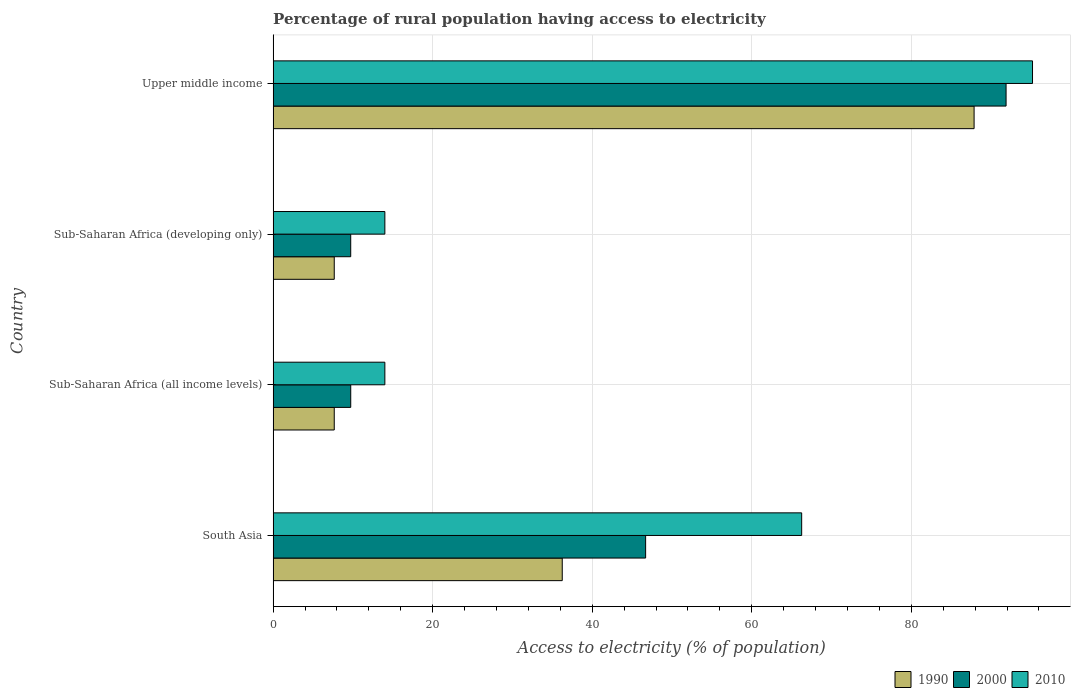How many different coloured bars are there?
Ensure brevity in your answer.  3. How many groups of bars are there?
Provide a succinct answer. 4. Are the number of bars on each tick of the Y-axis equal?
Offer a terse response. Yes. How many bars are there on the 2nd tick from the top?
Your answer should be very brief. 3. How many bars are there on the 1st tick from the bottom?
Provide a short and direct response. 3. What is the label of the 1st group of bars from the top?
Provide a succinct answer. Upper middle income. In how many cases, is the number of bars for a given country not equal to the number of legend labels?
Your answer should be very brief. 0. What is the percentage of rural population having access to electricity in 1990 in South Asia?
Offer a terse response. 36.24. Across all countries, what is the maximum percentage of rural population having access to electricity in 2010?
Offer a very short reply. 95.19. Across all countries, what is the minimum percentage of rural population having access to electricity in 1990?
Make the answer very short. 7.66. In which country was the percentage of rural population having access to electricity in 2000 maximum?
Offer a very short reply. Upper middle income. In which country was the percentage of rural population having access to electricity in 1990 minimum?
Offer a terse response. Sub-Saharan Africa (all income levels). What is the total percentage of rural population having access to electricity in 2000 in the graph?
Offer a terse response. 158.02. What is the difference between the percentage of rural population having access to electricity in 2000 in Sub-Saharan Africa (all income levels) and that in Sub-Saharan Africa (developing only)?
Provide a short and direct response. 0. What is the difference between the percentage of rural population having access to electricity in 2010 in Upper middle income and the percentage of rural population having access to electricity in 2000 in Sub-Saharan Africa (developing only)?
Offer a very short reply. 85.46. What is the average percentage of rural population having access to electricity in 1990 per country?
Offer a terse response. 34.86. What is the difference between the percentage of rural population having access to electricity in 2010 and percentage of rural population having access to electricity in 2000 in Upper middle income?
Offer a very short reply. 3.32. What is the ratio of the percentage of rural population having access to electricity in 2000 in Sub-Saharan Africa (all income levels) to that in Upper middle income?
Offer a terse response. 0.11. Is the difference between the percentage of rural population having access to electricity in 2010 in Sub-Saharan Africa (developing only) and Upper middle income greater than the difference between the percentage of rural population having access to electricity in 2000 in Sub-Saharan Africa (developing only) and Upper middle income?
Provide a short and direct response. Yes. What is the difference between the highest and the second highest percentage of rural population having access to electricity in 1990?
Make the answer very short. 51.63. What is the difference between the highest and the lowest percentage of rural population having access to electricity in 2000?
Offer a terse response. 82.15. In how many countries, is the percentage of rural population having access to electricity in 1990 greater than the average percentage of rural population having access to electricity in 1990 taken over all countries?
Provide a succinct answer. 2. What does the 2nd bar from the bottom in Sub-Saharan Africa (all income levels) represents?
Keep it short and to the point. 2000. Is it the case that in every country, the sum of the percentage of rural population having access to electricity in 1990 and percentage of rural population having access to electricity in 2010 is greater than the percentage of rural population having access to electricity in 2000?
Offer a very short reply. Yes. Does the graph contain grids?
Your answer should be compact. Yes. How many legend labels are there?
Your answer should be very brief. 3. What is the title of the graph?
Keep it short and to the point. Percentage of rural population having access to electricity. Does "2014" appear as one of the legend labels in the graph?
Offer a terse response. No. What is the label or title of the X-axis?
Provide a succinct answer. Access to electricity (% of population). What is the Access to electricity (% of population) in 1990 in South Asia?
Your response must be concise. 36.24. What is the Access to electricity (% of population) of 2000 in South Asia?
Provide a short and direct response. 46.69. What is the Access to electricity (% of population) in 2010 in South Asia?
Your answer should be compact. 66.25. What is the Access to electricity (% of population) of 1990 in Sub-Saharan Africa (all income levels)?
Keep it short and to the point. 7.66. What is the Access to electricity (% of population) in 2000 in Sub-Saharan Africa (all income levels)?
Make the answer very short. 9.73. What is the Access to electricity (% of population) of 2010 in Sub-Saharan Africa (all income levels)?
Make the answer very short. 14.01. What is the Access to electricity (% of population) in 1990 in Sub-Saharan Africa (developing only)?
Provide a succinct answer. 7.66. What is the Access to electricity (% of population) in 2000 in Sub-Saharan Africa (developing only)?
Provide a short and direct response. 9.73. What is the Access to electricity (% of population) of 2010 in Sub-Saharan Africa (developing only)?
Give a very brief answer. 14.01. What is the Access to electricity (% of population) of 1990 in Upper middle income?
Ensure brevity in your answer.  87.87. What is the Access to electricity (% of population) in 2000 in Upper middle income?
Ensure brevity in your answer.  91.87. What is the Access to electricity (% of population) in 2010 in Upper middle income?
Offer a very short reply. 95.19. Across all countries, what is the maximum Access to electricity (% of population) of 1990?
Your response must be concise. 87.87. Across all countries, what is the maximum Access to electricity (% of population) in 2000?
Provide a succinct answer. 91.87. Across all countries, what is the maximum Access to electricity (% of population) of 2010?
Give a very brief answer. 95.19. Across all countries, what is the minimum Access to electricity (% of population) of 1990?
Give a very brief answer. 7.66. Across all countries, what is the minimum Access to electricity (% of population) of 2000?
Offer a terse response. 9.73. Across all countries, what is the minimum Access to electricity (% of population) in 2010?
Your answer should be very brief. 14.01. What is the total Access to electricity (% of population) of 1990 in the graph?
Ensure brevity in your answer.  139.43. What is the total Access to electricity (% of population) in 2000 in the graph?
Your response must be concise. 158.02. What is the total Access to electricity (% of population) of 2010 in the graph?
Ensure brevity in your answer.  189.46. What is the difference between the Access to electricity (% of population) in 1990 in South Asia and that in Sub-Saharan Africa (all income levels)?
Your answer should be very brief. 28.58. What is the difference between the Access to electricity (% of population) in 2000 in South Asia and that in Sub-Saharan Africa (all income levels)?
Offer a very short reply. 36.96. What is the difference between the Access to electricity (% of population) in 2010 in South Asia and that in Sub-Saharan Africa (all income levels)?
Your response must be concise. 52.25. What is the difference between the Access to electricity (% of population) in 1990 in South Asia and that in Sub-Saharan Africa (developing only)?
Provide a succinct answer. 28.58. What is the difference between the Access to electricity (% of population) of 2000 in South Asia and that in Sub-Saharan Africa (developing only)?
Make the answer very short. 36.97. What is the difference between the Access to electricity (% of population) of 2010 in South Asia and that in Sub-Saharan Africa (developing only)?
Offer a terse response. 52.25. What is the difference between the Access to electricity (% of population) of 1990 in South Asia and that in Upper middle income?
Give a very brief answer. -51.62. What is the difference between the Access to electricity (% of population) of 2000 in South Asia and that in Upper middle income?
Ensure brevity in your answer.  -45.18. What is the difference between the Access to electricity (% of population) of 2010 in South Asia and that in Upper middle income?
Your answer should be compact. -28.94. What is the difference between the Access to electricity (% of population) of 1990 in Sub-Saharan Africa (all income levels) and that in Sub-Saharan Africa (developing only)?
Provide a succinct answer. -0. What is the difference between the Access to electricity (% of population) in 2000 in Sub-Saharan Africa (all income levels) and that in Sub-Saharan Africa (developing only)?
Make the answer very short. 0. What is the difference between the Access to electricity (% of population) of 1990 in Sub-Saharan Africa (all income levels) and that in Upper middle income?
Offer a very short reply. -80.2. What is the difference between the Access to electricity (% of population) of 2000 in Sub-Saharan Africa (all income levels) and that in Upper middle income?
Ensure brevity in your answer.  -82.15. What is the difference between the Access to electricity (% of population) in 2010 in Sub-Saharan Africa (all income levels) and that in Upper middle income?
Provide a succinct answer. -81.18. What is the difference between the Access to electricity (% of population) of 1990 in Sub-Saharan Africa (developing only) and that in Upper middle income?
Provide a short and direct response. -80.2. What is the difference between the Access to electricity (% of population) of 2000 in Sub-Saharan Africa (developing only) and that in Upper middle income?
Offer a terse response. -82.15. What is the difference between the Access to electricity (% of population) of 2010 in Sub-Saharan Africa (developing only) and that in Upper middle income?
Offer a terse response. -81.18. What is the difference between the Access to electricity (% of population) of 1990 in South Asia and the Access to electricity (% of population) of 2000 in Sub-Saharan Africa (all income levels)?
Offer a very short reply. 26.51. What is the difference between the Access to electricity (% of population) of 1990 in South Asia and the Access to electricity (% of population) of 2010 in Sub-Saharan Africa (all income levels)?
Give a very brief answer. 22.23. What is the difference between the Access to electricity (% of population) of 2000 in South Asia and the Access to electricity (% of population) of 2010 in Sub-Saharan Africa (all income levels)?
Ensure brevity in your answer.  32.69. What is the difference between the Access to electricity (% of population) of 1990 in South Asia and the Access to electricity (% of population) of 2000 in Sub-Saharan Africa (developing only)?
Your answer should be very brief. 26.51. What is the difference between the Access to electricity (% of population) in 1990 in South Asia and the Access to electricity (% of population) in 2010 in Sub-Saharan Africa (developing only)?
Offer a terse response. 22.23. What is the difference between the Access to electricity (% of population) of 2000 in South Asia and the Access to electricity (% of population) of 2010 in Sub-Saharan Africa (developing only)?
Provide a short and direct response. 32.69. What is the difference between the Access to electricity (% of population) of 1990 in South Asia and the Access to electricity (% of population) of 2000 in Upper middle income?
Give a very brief answer. -55.63. What is the difference between the Access to electricity (% of population) in 1990 in South Asia and the Access to electricity (% of population) in 2010 in Upper middle income?
Your response must be concise. -58.95. What is the difference between the Access to electricity (% of population) of 2000 in South Asia and the Access to electricity (% of population) of 2010 in Upper middle income?
Your answer should be compact. -48.5. What is the difference between the Access to electricity (% of population) in 1990 in Sub-Saharan Africa (all income levels) and the Access to electricity (% of population) in 2000 in Sub-Saharan Africa (developing only)?
Your response must be concise. -2.07. What is the difference between the Access to electricity (% of population) in 1990 in Sub-Saharan Africa (all income levels) and the Access to electricity (% of population) in 2010 in Sub-Saharan Africa (developing only)?
Your response must be concise. -6.34. What is the difference between the Access to electricity (% of population) in 2000 in Sub-Saharan Africa (all income levels) and the Access to electricity (% of population) in 2010 in Sub-Saharan Africa (developing only)?
Ensure brevity in your answer.  -4.28. What is the difference between the Access to electricity (% of population) of 1990 in Sub-Saharan Africa (all income levels) and the Access to electricity (% of population) of 2000 in Upper middle income?
Give a very brief answer. -84.21. What is the difference between the Access to electricity (% of population) in 1990 in Sub-Saharan Africa (all income levels) and the Access to electricity (% of population) in 2010 in Upper middle income?
Your response must be concise. -87.53. What is the difference between the Access to electricity (% of population) in 2000 in Sub-Saharan Africa (all income levels) and the Access to electricity (% of population) in 2010 in Upper middle income?
Your answer should be very brief. -85.46. What is the difference between the Access to electricity (% of population) in 1990 in Sub-Saharan Africa (developing only) and the Access to electricity (% of population) in 2000 in Upper middle income?
Offer a very short reply. -84.21. What is the difference between the Access to electricity (% of population) in 1990 in Sub-Saharan Africa (developing only) and the Access to electricity (% of population) in 2010 in Upper middle income?
Offer a very short reply. -87.53. What is the difference between the Access to electricity (% of population) in 2000 in Sub-Saharan Africa (developing only) and the Access to electricity (% of population) in 2010 in Upper middle income?
Give a very brief answer. -85.46. What is the average Access to electricity (% of population) of 1990 per country?
Your answer should be compact. 34.86. What is the average Access to electricity (% of population) of 2000 per country?
Your answer should be very brief. 39.51. What is the average Access to electricity (% of population) in 2010 per country?
Your answer should be very brief. 47.36. What is the difference between the Access to electricity (% of population) of 1990 and Access to electricity (% of population) of 2000 in South Asia?
Ensure brevity in your answer.  -10.45. What is the difference between the Access to electricity (% of population) in 1990 and Access to electricity (% of population) in 2010 in South Asia?
Your response must be concise. -30.01. What is the difference between the Access to electricity (% of population) in 2000 and Access to electricity (% of population) in 2010 in South Asia?
Make the answer very short. -19.56. What is the difference between the Access to electricity (% of population) of 1990 and Access to electricity (% of population) of 2000 in Sub-Saharan Africa (all income levels)?
Keep it short and to the point. -2.07. What is the difference between the Access to electricity (% of population) in 1990 and Access to electricity (% of population) in 2010 in Sub-Saharan Africa (all income levels)?
Provide a short and direct response. -6.35. What is the difference between the Access to electricity (% of population) of 2000 and Access to electricity (% of population) of 2010 in Sub-Saharan Africa (all income levels)?
Keep it short and to the point. -4.28. What is the difference between the Access to electricity (% of population) of 1990 and Access to electricity (% of population) of 2000 in Sub-Saharan Africa (developing only)?
Offer a terse response. -2.06. What is the difference between the Access to electricity (% of population) of 1990 and Access to electricity (% of population) of 2010 in Sub-Saharan Africa (developing only)?
Keep it short and to the point. -6.34. What is the difference between the Access to electricity (% of population) in 2000 and Access to electricity (% of population) in 2010 in Sub-Saharan Africa (developing only)?
Your response must be concise. -4.28. What is the difference between the Access to electricity (% of population) of 1990 and Access to electricity (% of population) of 2000 in Upper middle income?
Offer a very short reply. -4.01. What is the difference between the Access to electricity (% of population) of 1990 and Access to electricity (% of population) of 2010 in Upper middle income?
Offer a very short reply. -7.32. What is the difference between the Access to electricity (% of population) in 2000 and Access to electricity (% of population) in 2010 in Upper middle income?
Offer a very short reply. -3.32. What is the ratio of the Access to electricity (% of population) of 1990 in South Asia to that in Sub-Saharan Africa (all income levels)?
Make the answer very short. 4.73. What is the ratio of the Access to electricity (% of population) in 2000 in South Asia to that in Sub-Saharan Africa (all income levels)?
Your response must be concise. 4.8. What is the ratio of the Access to electricity (% of population) of 2010 in South Asia to that in Sub-Saharan Africa (all income levels)?
Your response must be concise. 4.73. What is the ratio of the Access to electricity (% of population) of 1990 in South Asia to that in Sub-Saharan Africa (developing only)?
Your response must be concise. 4.73. What is the ratio of the Access to electricity (% of population) of 2000 in South Asia to that in Sub-Saharan Africa (developing only)?
Provide a succinct answer. 4.8. What is the ratio of the Access to electricity (% of population) in 2010 in South Asia to that in Sub-Saharan Africa (developing only)?
Your answer should be very brief. 4.73. What is the ratio of the Access to electricity (% of population) in 1990 in South Asia to that in Upper middle income?
Offer a terse response. 0.41. What is the ratio of the Access to electricity (% of population) of 2000 in South Asia to that in Upper middle income?
Offer a terse response. 0.51. What is the ratio of the Access to electricity (% of population) in 2010 in South Asia to that in Upper middle income?
Offer a terse response. 0.7. What is the ratio of the Access to electricity (% of population) in 1990 in Sub-Saharan Africa (all income levels) to that in Sub-Saharan Africa (developing only)?
Give a very brief answer. 1. What is the ratio of the Access to electricity (% of population) in 2010 in Sub-Saharan Africa (all income levels) to that in Sub-Saharan Africa (developing only)?
Your answer should be compact. 1. What is the ratio of the Access to electricity (% of population) in 1990 in Sub-Saharan Africa (all income levels) to that in Upper middle income?
Provide a succinct answer. 0.09. What is the ratio of the Access to electricity (% of population) of 2000 in Sub-Saharan Africa (all income levels) to that in Upper middle income?
Your answer should be compact. 0.11. What is the ratio of the Access to electricity (% of population) of 2010 in Sub-Saharan Africa (all income levels) to that in Upper middle income?
Your answer should be compact. 0.15. What is the ratio of the Access to electricity (% of population) in 1990 in Sub-Saharan Africa (developing only) to that in Upper middle income?
Your response must be concise. 0.09. What is the ratio of the Access to electricity (% of population) of 2000 in Sub-Saharan Africa (developing only) to that in Upper middle income?
Your response must be concise. 0.11. What is the ratio of the Access to electricity (% of population) in 2010 in Sub-Saharan Africa (developing only) to that in Upper middle income?
Make the answer very short. 0.15. What is the difference between the highest and the second highest Access to electricity (% of population) in 1990?
Your answer should be very brief. 51.62. What is the difference between the highest and the second highest Access to electricity (% of population) in 2000?
Give a very brief answer. 45.18. What is the difference between the highest and the second highest Access to electricity (% of population) of 2010?
Offer a terse response. 28.94. What is the difference between the highest and the lowest Access to electricity (% of population) in 1990?
Provide a short and direct response. 80.2. What is the difference between the highest and the lowest Access to electricity (% of population) of 2000?
Give a very brief answer. 82.15. What is the difference between the highest and the lowest Access to electricity (% of population) in 2010?
Provide a short and direct response. 81.18. 